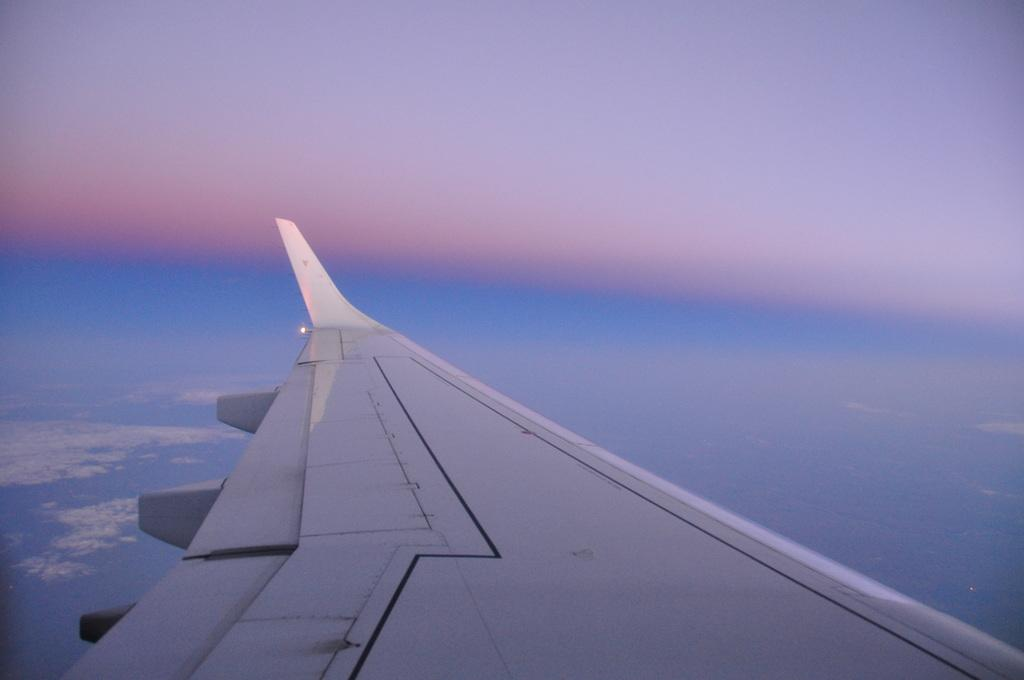What is the main subject of the picture? The main subject of the picture is an airplane wing. What can be seen in the background of the picture? The sky is visible in the background of the picture. What type of reaction can be seen from the scissors in the image? There are no scissors present in the image, so it is not possible to determine any reaction from them. 